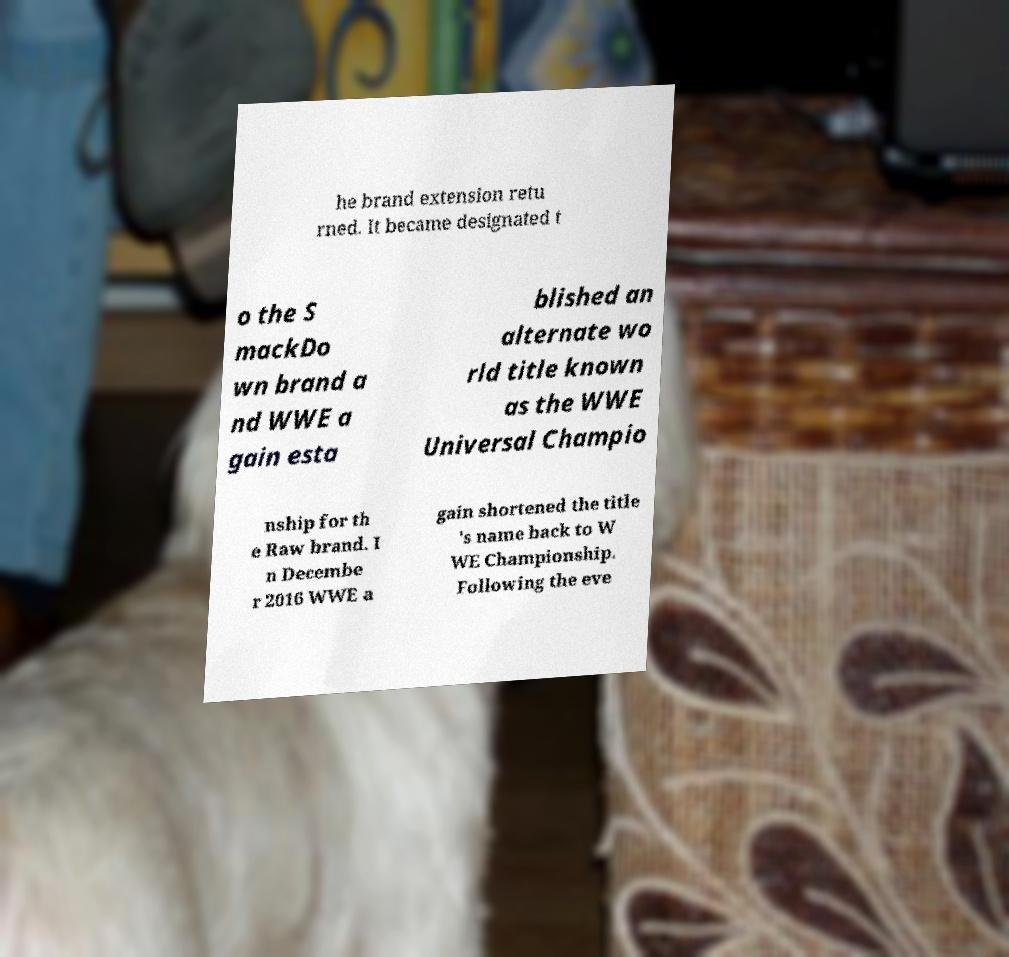I need the written content from this picture converted into text. Can you do that? he brand extension retu rned. It became designated t o the S mackDo wn brand a nd WWE a gain esta blished an alternate wo rld title known as the WWE Universal Champio nship for th e Raw brand. I n Decembe r 2016 WWE a gain shortened the title 's name back to W WE Championship. Following the eve 